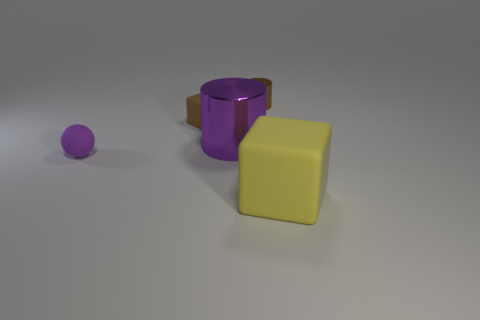Add 1 tiny brown matte things. How many objects exist? 6 Subtract all balls. How many objects are left? 4 Add 4 metal cylinders. How many metal cylinders are left? 6 Add 3 yellow matte objects. How many yellow matte objects exist? 4 Subtract 0 cyan spheres. How many objects are left? 5 Subtract all large brown cubes. Subtract all big rubber objects. How many objects are left? 4 